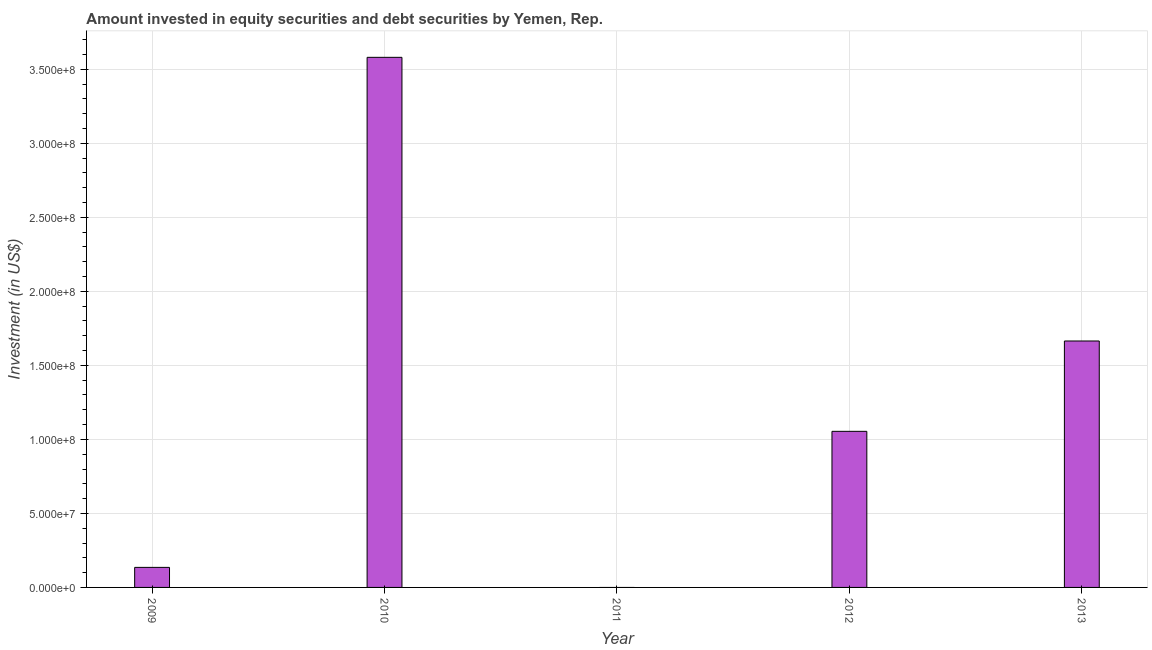What is the title of the graph?
Give a very brief answer. Amount invested in equity securities and debt securities by Yemen, Rep. What is the label or title of the X-axis?
Give a very brief answer. Year. What is the label or title of the Y-axis?
Your answer should be very brief. Investment (in US$). What is the portfolio investment in 2009?
Ensure brevity in your answer.  1.35e+07. Across all years, what is the maximum portfolio investment?
Keep it short and to the point. 3.58e+08. Across all years, what is the minimum portfolio investment?
Make the answer very short. 0. What is the sum of the portfolio investment?
Your response must be concise. 6.44e+08. What is the difference between the portfolio investment in 2010 and 2012?
Keep it short and to the point. 2.53e+08. What is the average portfolio investment per year?
Offer a very short reply. 1.29e+08. What is the median portfolio investment?
Provide a short and direct response. 1.05e+08. In how many years, is the portfolio investment greater than 190000000 US$?
Your response must be concise. 1. What is the ratio of the portfolio investment in 2010 to that in 2012?
Keep it short and to the point. 3.4. What is the difference between the highest and the second highest portfolio investment?
Provide a succinct answer. 1.92e+08. What is the difference between the highest and the lowest portfolio investment?
Your response must be concise. 3.58e+08. In how many years, is the portfolio investment greater than the average portfolio investment taken over all years?
Your response must be concise. 2. How many bars are there?
Provide a short and direct response. 4. How many years are there in the graph?
Give a very brief answer. 5. What is the Investment (in US$) of 2009?
Your answer should be very brief. 1.35e+07. What is the Investment (in US$) in 2010?
Your answer should be very brief. 3.58e+08. What is the Investment (in US$) in 2011?
Provide a succinct answer. 0. What is the Investment (in US$) of 2012?
Your answer should be compact. 1.05e+08. What is the Investment (in US$) of 2013?
Your answer should be very brief. 1.66e+08. What is the difference between the Investment (in US$) in 2009 and 2010?
Offer a terse response. -3.45e+08. What is the difference between the Investment (in US$) in 2009 and 2012?
Make the answer very short. -9.19e+07. What is the difference between the Investment (in US$) in 2009 and 2013?
Offer a terse response. -1.53e+08. What is the difference between the Investment (in US$) in 2010 and 2012?
Your response must be concise. 2.53e+08. What is the difference between the Investment (in US$) in 2010 and 2013?
Your response must be concise. 1.92e+08. What is the difference between the Investment (in US$) in 2012 and 2013?
Your response must be concise. -6.10e+07. What is the ratio of the Investment (in US$) in 2009 to that in 2010?
Ensure brevity in your answer.  0.04. What is the ratio of the Investment (in US$) in 2009 to that in 2012?
Make the answer very short. 0.13. What is the ratio of the Investment (in US$) in 2009 to that in 2013?
Ensure brevity in your answer.  0.08. What is the ratio of the Investment (in US$) in 2010 to that in 2012?
Provide a short and direct response. 3.4. What is the ratio of the Investment (in US$) in 2010 to that in 2013?
Keep it short and to the point. 2.15. What is the ratio of the Investment (in US$) in 2012 to that in 2013?
Your answer should be very brief. 0.63. 